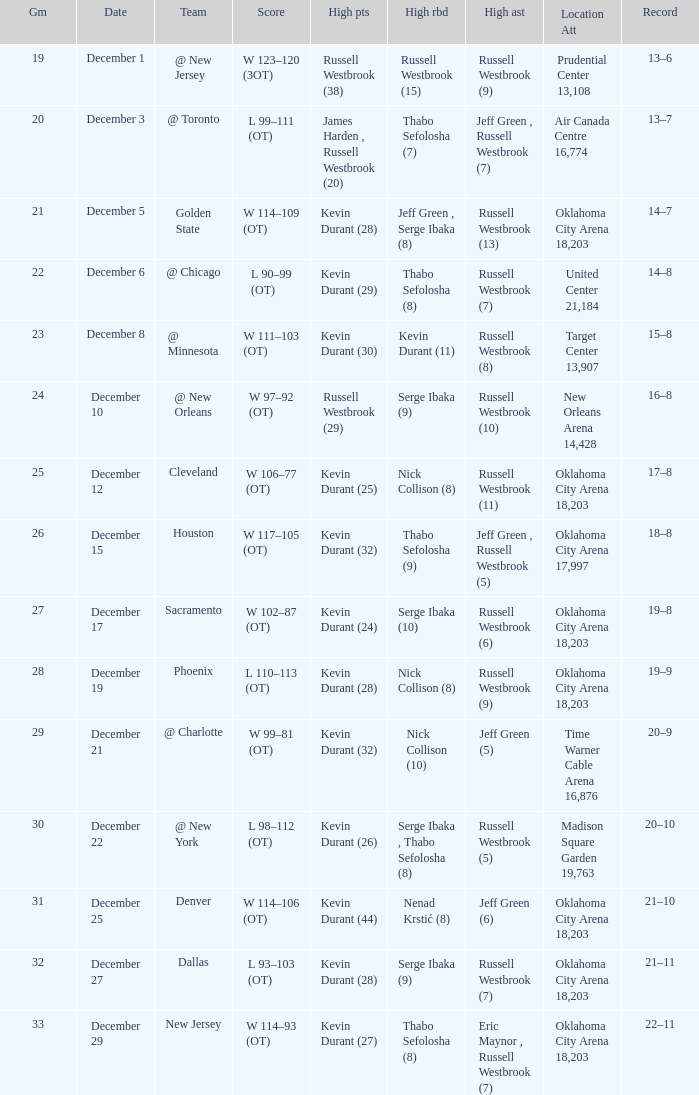Who had the high rebounds record on December 12? Nick Collison (8). 